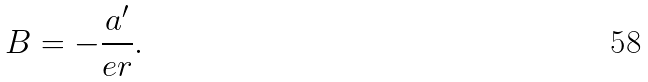<formula> <loc_0><loc_0><loc_500><loc_500>B = - \frac { a ^ { \prime } } { e r } .</formula> 